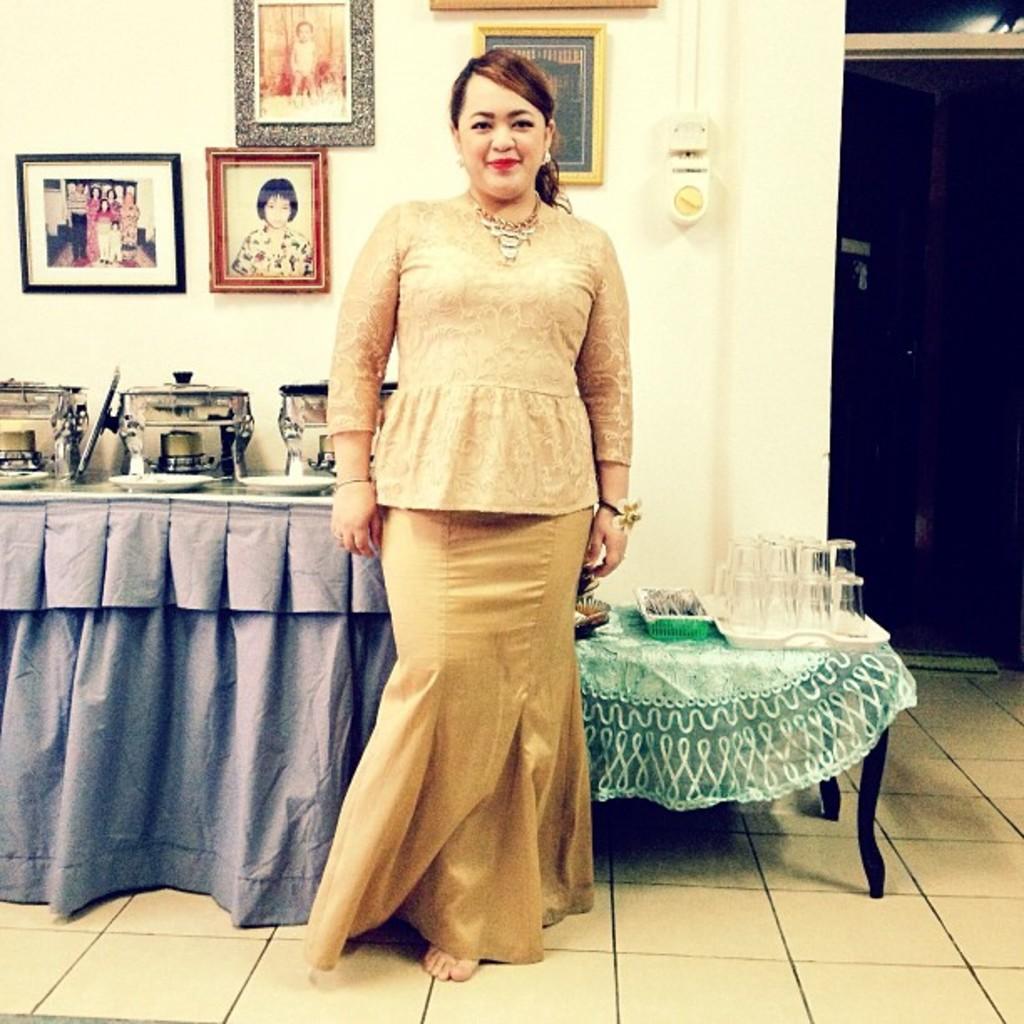Describe this image in one or two sentences. In this picture we can see woman smiling and standing on floor and beside to her we have tables and on table we can see dishes, plates, tray with glasses, basket with spoons and in background we can see way, wall with frames. 